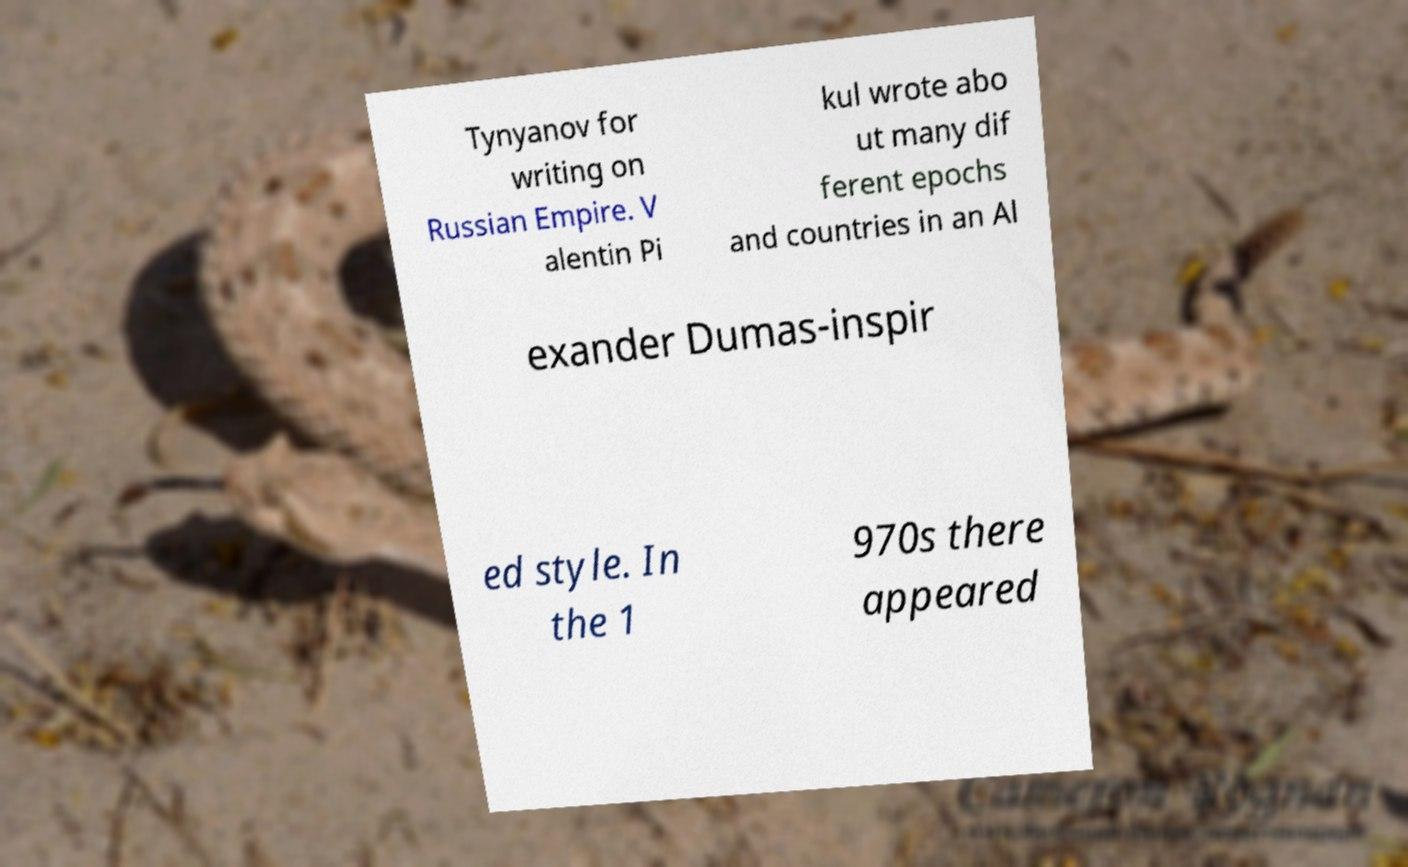Please read and relay the text visible in this image. What does it say? Tynyanov for writing on Russian Empire. V alentin Pi kul wrote abo ut many dif ferent epochs and countries in an Al exander Dumas-inspir ed style. In the 1 970s there appeared 